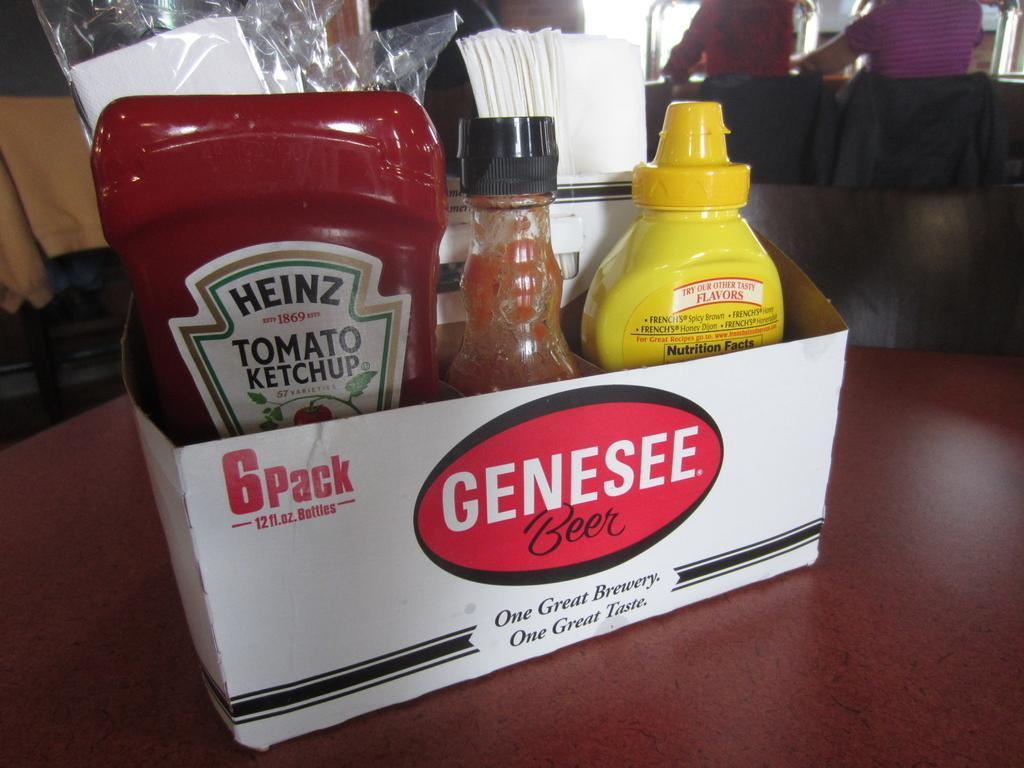<image>
Provide a brief description of the given image. Some condiments including ketchup and mustard in a Genesee beer box. 